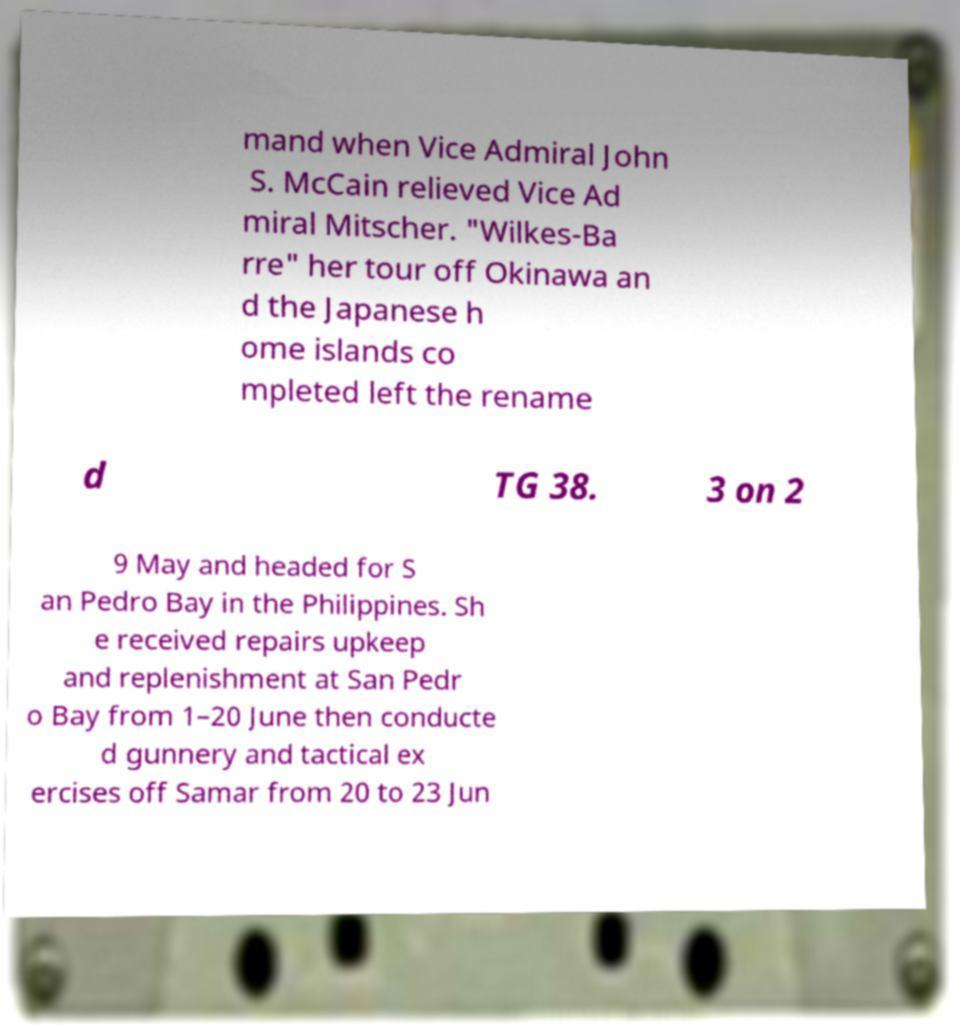For documentation purposes, I need the text within this image transcribed. Could you provide that? mand when Vice Admiral John S. McCain relieved Vice Ad miral Mitscher. "Wilkes-Ba rre" her tour off Okinawa an d the Japanese h ome islands co mpleted left the rename d TG 38. 3 on 2 9 May and headed for S an Pedro Bay in the Philippines. Sh e received repairs upkeep and replenishment at San Pedr o Bay from 1–20 June then conducte d gunnery and tactical ex ercises off Samar from 20 to 23 Jun 